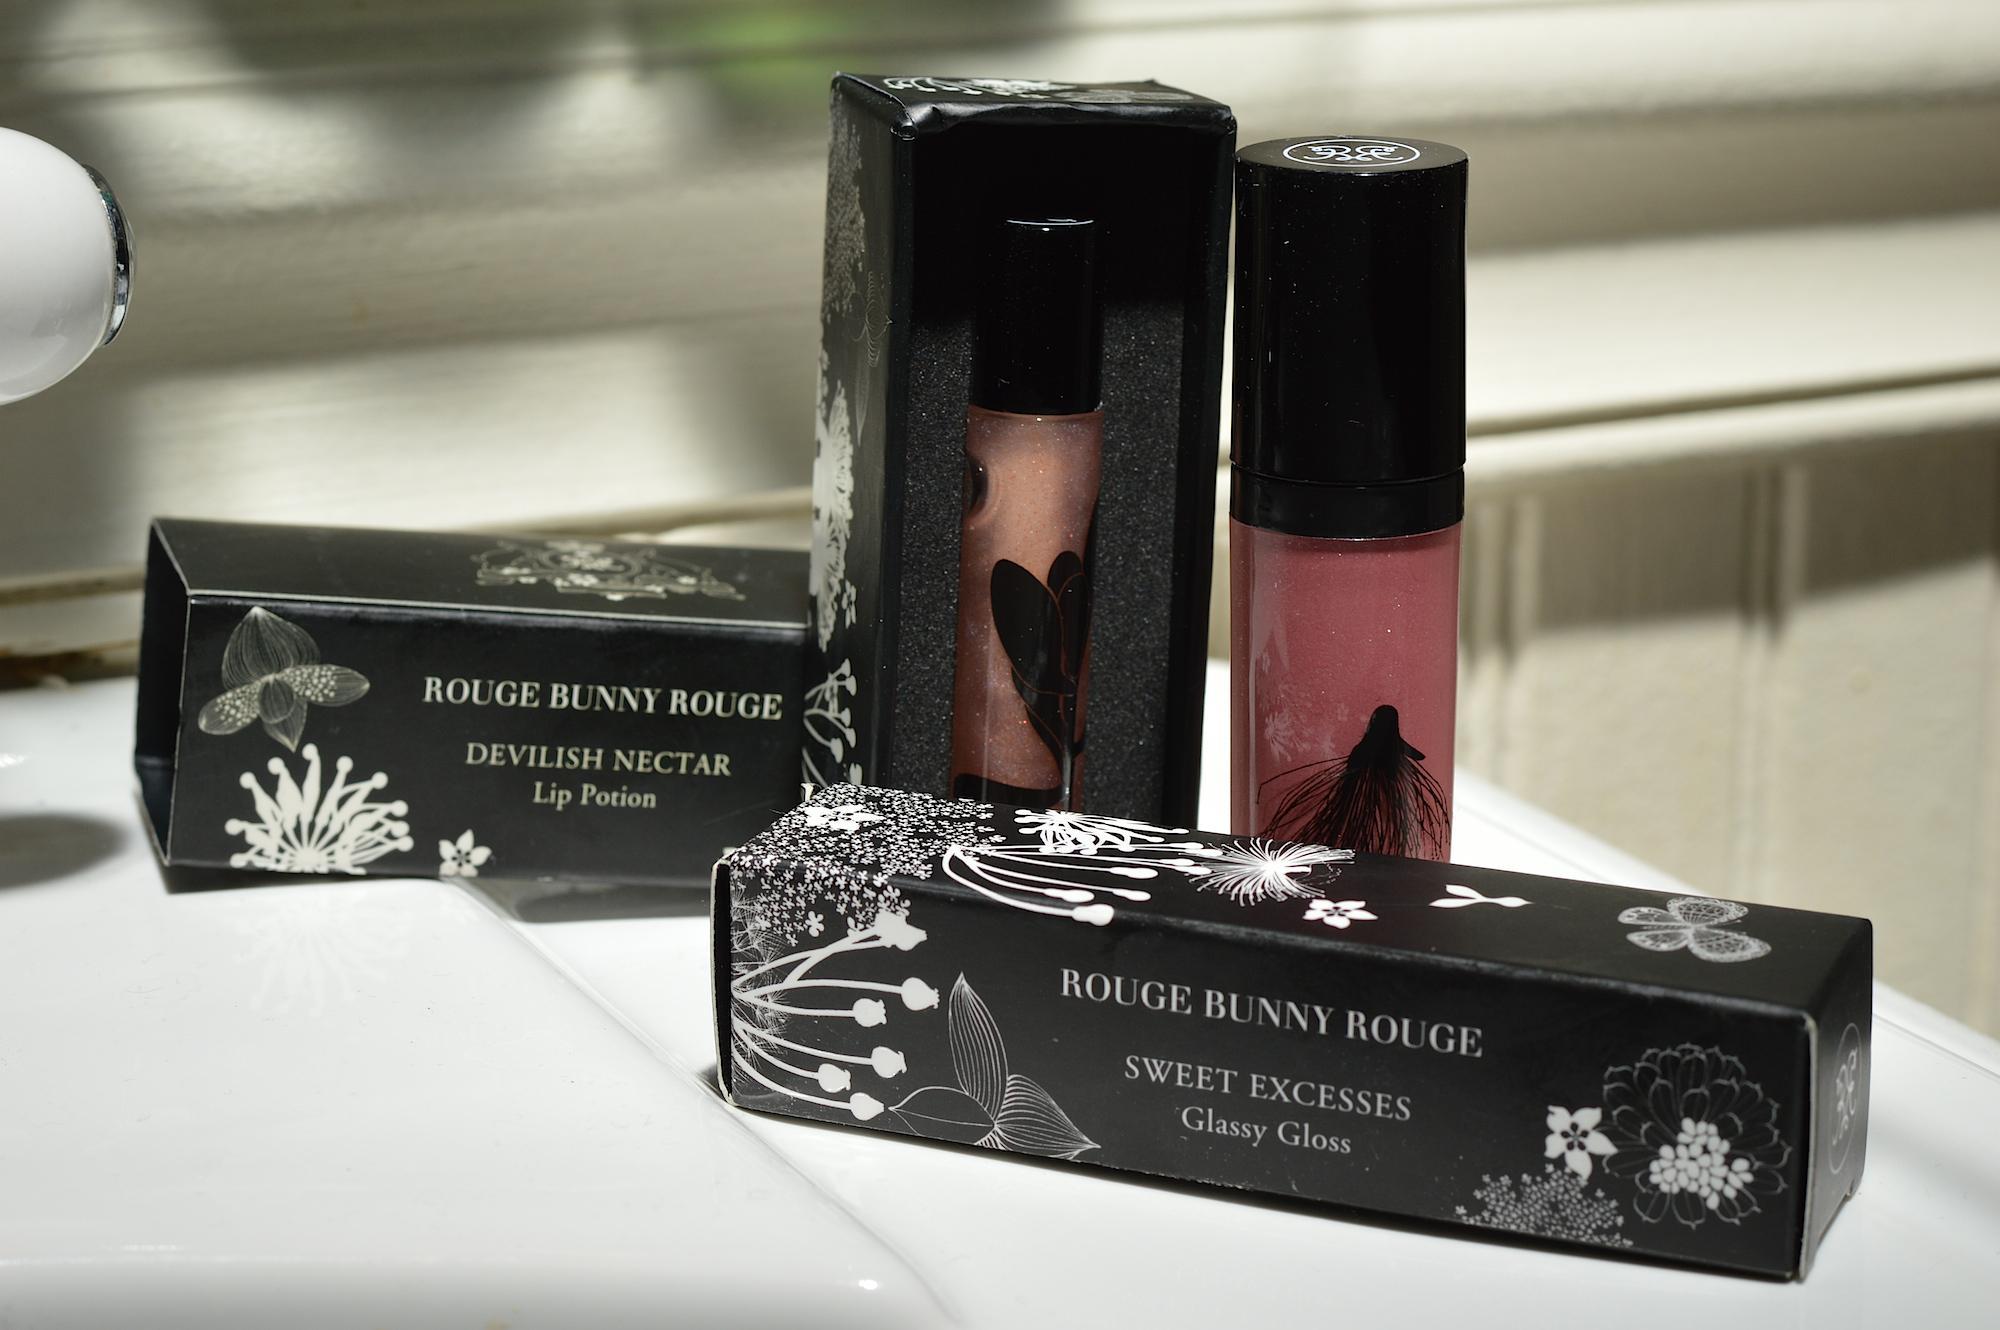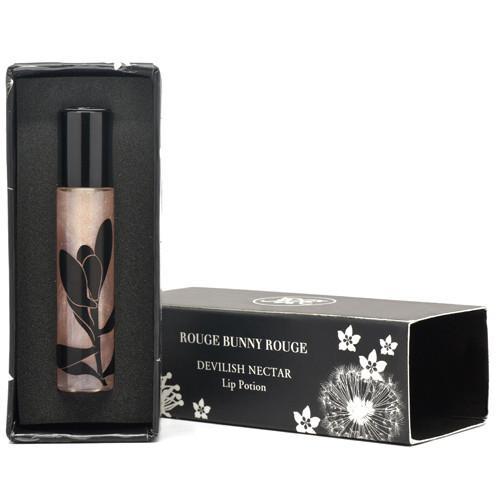The first image is the image on the left, the second image is the image on the right. Considering the images on both sides, is "Lip applicants are displayed in a line of 11 or more." valid? Answer yes or no. No. 